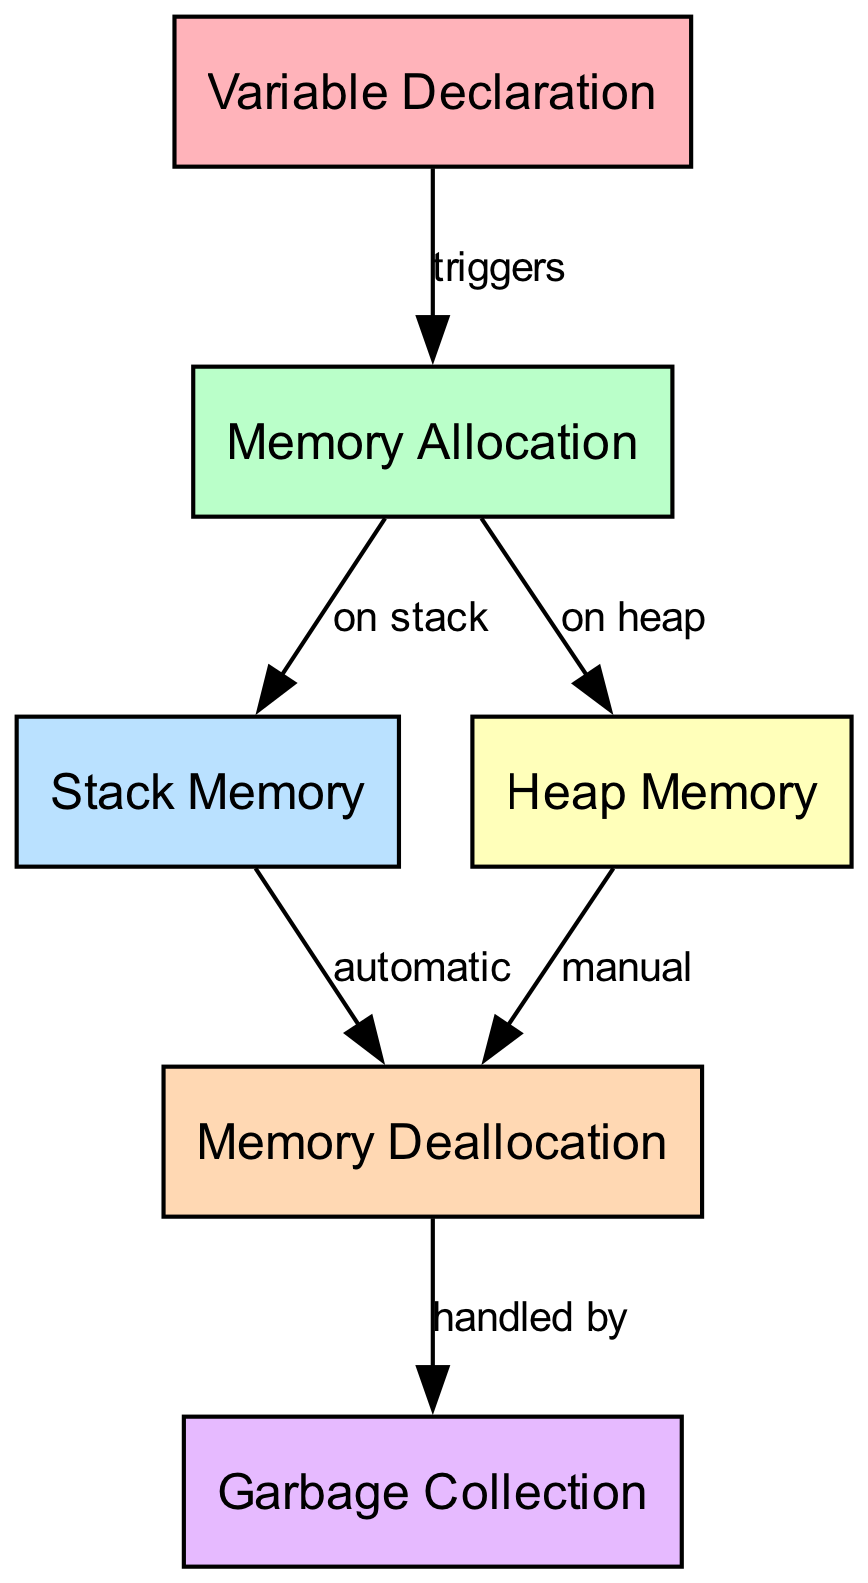What triggers Memory Allocation? The diagram indicates that Variable Declaration directly triggers Memory Allocation, as represented by the arrow labeled "triggers" connecting the two nodes.
Answer: Variable Declaration How is Memory Deallocation handled for Heap Memory? The diagram shows that Memory Deallocation for Heap Memory is labeled as "manual," indicating that the programmer must explicitly free the memory allocated on the heap.
Answer: manual What type of memory is Stack Memory? The diagram specifies that Stack Memory follows the Memory Allocation node, and it is connected by the labeled edge "on stack," denoting that it is indeed a type of memory allocation.
Answer: on stack How many total nodes are present in the diagram? By counting the nodes in the diagram, we find there are six distinct nodes: Variable Declaration, Memory Allocation, Stack Memory, Heap Memory, Memory Deallocation, and Garbage Collection.
Answer: six What handles Memory Deallocation? According to the diagram, Memory Deallocation is handled by Garbage Collection, as indicated by the edge labeled "handled by."
Answer: Garbage Collection What type of memory is automatically deallocated? The diagram indicates that Stack Memory is automatically deallocated, having an edge labeled "automatic" connected to Memory Deallocation.
Answer: automatic Which memory requires manual deallocation? The diagram shows that Heap Memory is associated with manual deallocation, represented by the edge leading to Memory Deallocation labeled "manual."
Answer: manual What is the sequence from Variable Declaration to Garbage Collection? The sequence starts from Variable Declaration, which triggers Memory Allocation; this leads to both Stack Memory and Heap Memory; Stack Memory automatically goes to Memory Deallocation; Heap Memory requires manual memory deallocation, which is handled by Garbage Collection.
Answer: Variable Declaration → Memory Allocation → Stack Memory → Memory Deallocation → Garbage Collection 